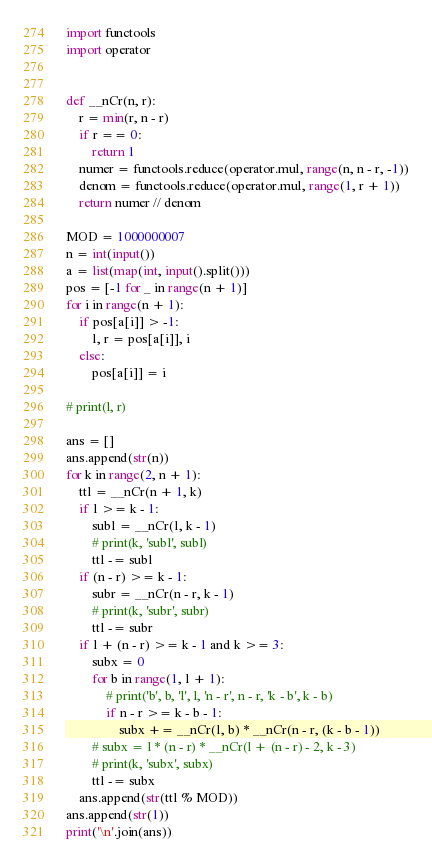Convert code to text. <code><loc_0><loc_0><loc_500><loc_500><_Python_>import functools
import operator


def __nCr(n, r):
    r = min(r, n - r)
    if r == 0:
        return 1
    numer = functools.reduce(operator.mul, range(n, n - r, -1))
    denom = functools.reduce(operator.mul, range(1, r + 1))
    return numer // denom

MOD = 1000000007
n = int(input())
a = list(map(int, input().split()))
pos = [-1 for _ in range(n + 1)]
for i in range(n + 1):
    if pos[a[i]] > -1:
        l, r = pos[a[i]], i
    else:
        pos[a[i]] = i

# print(l, r)

ans = []
ans.append(str(n))
for k in range(2, n + 1):
    ttl = __nCr(n + 1, k)
    if l >= k - 1:
        subl = __nCr(l, k - 1)
        # print(k, 'subl', subl)
        ttl -= subl
    if (n - r) >= k - 1:
        subr = __nCr(n - r, k - 1)
        # print(k, 'subr', subr)
        ttl -= subr
    if l + (n - r) >= k - 1 and k >= 3:
        subx = 0
        for b in range(1, l + 1):
            # print('b', b, 'l', l, 'n - r', n - r, 'k - b', k - b)
            if n - r >= k - b - 1:
                subx += __nCr(l, b) * __nCr(n - r, (k - b - 1))
        # subx = l * (n - r) * __nCr(l + (n - r) - 2, k - 3)
        # print(k, 'subx', subx)
        ttl -= subx
    ans.append(str(ttl % MOD))
ans.append(str(1))
print('\n'.join(ans))
</code> 